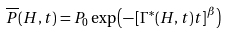<formula> <loc_0><loc_0><loc_500><loc_500>\overline { P } ( H , t ) = P _ { 0 } \exp \left ( - \left [ \Gamma ^ { \ast } ( H , t ) t \right ] ^ { \beta } \right )</formula> 